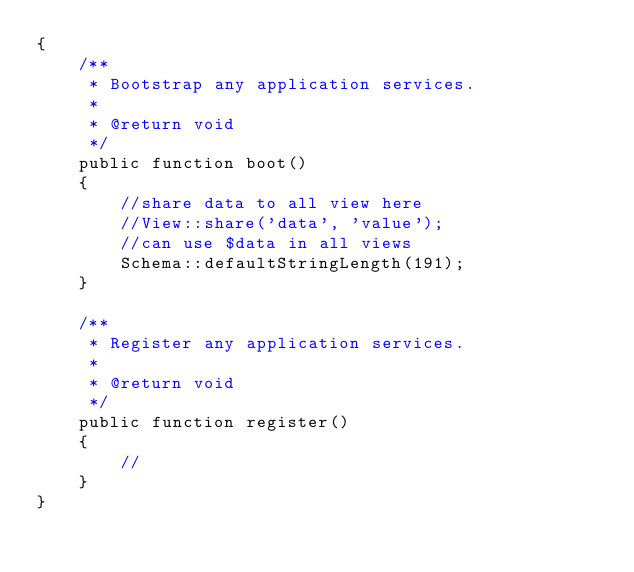Convert code to text. <code><loc_0><loc_0><loc_500><loc_500><_PHP_>{
    /**
     * Bootstrap any application services.
     *
     * @return void
     */
    public function boot()
    {
        //share data to all view here
        //View::share('data', 'value');
        //can use $data in all views
        Schema::defaultStringLength(191);
    }

    /**
     * Register any application services.
     *
     * @return void
     */
    public function register()
    {
        //
    }
}
</code> 